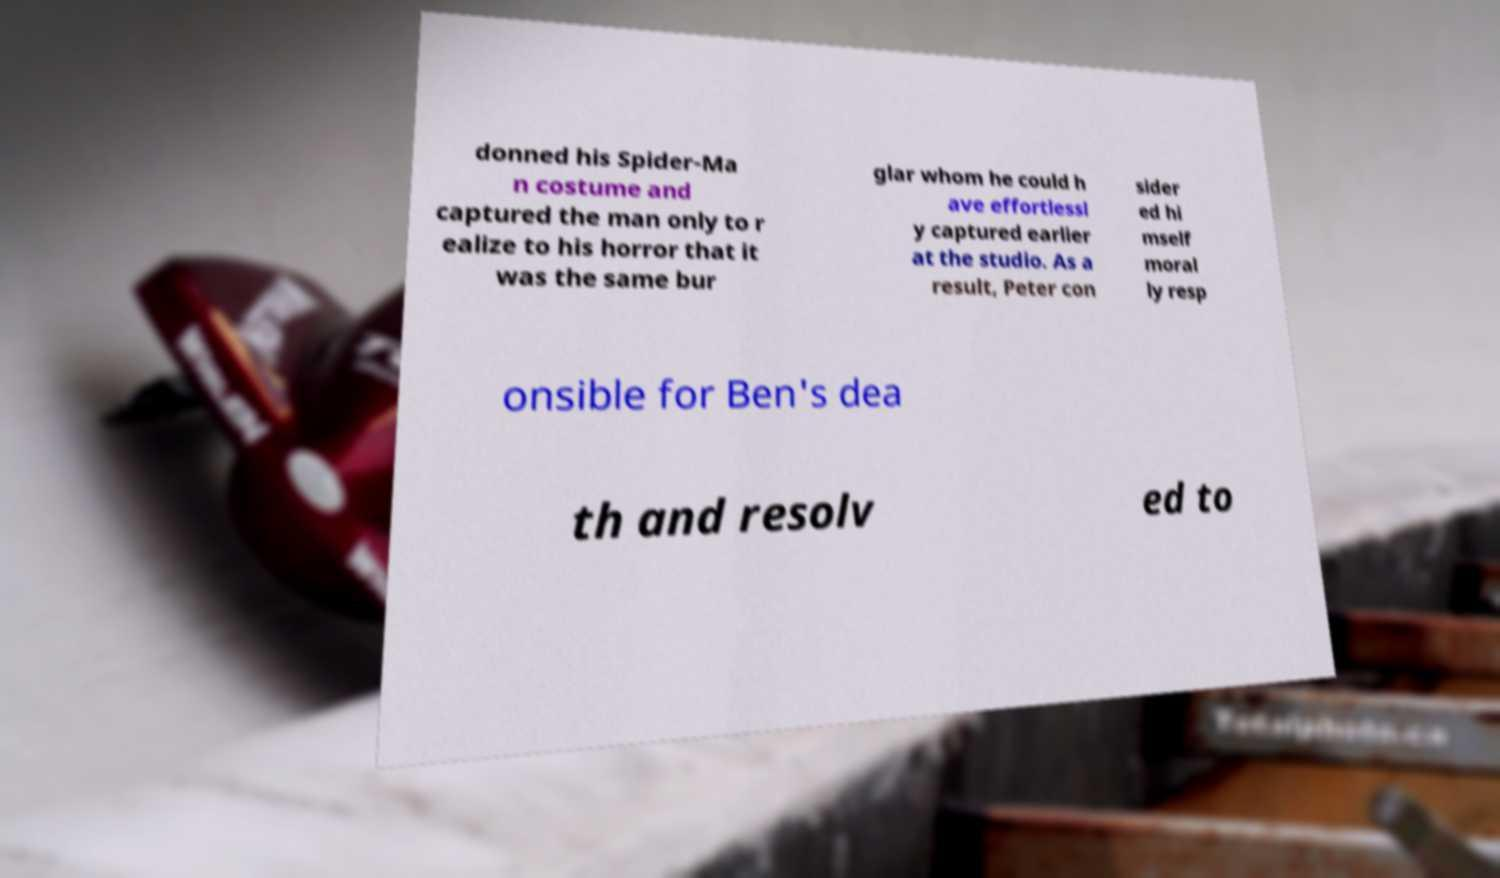Please identify and transcribe the text found in this image. donned his Spider-Ma n costume and captured the man only to r ealize to his horror that it was the same bur glar whom he could h ave effortlessl y captured earlier at the studio. As a result, Peter con sider ed hi mself moral ly resp onsible for Ben's dea th and resolv ed to 